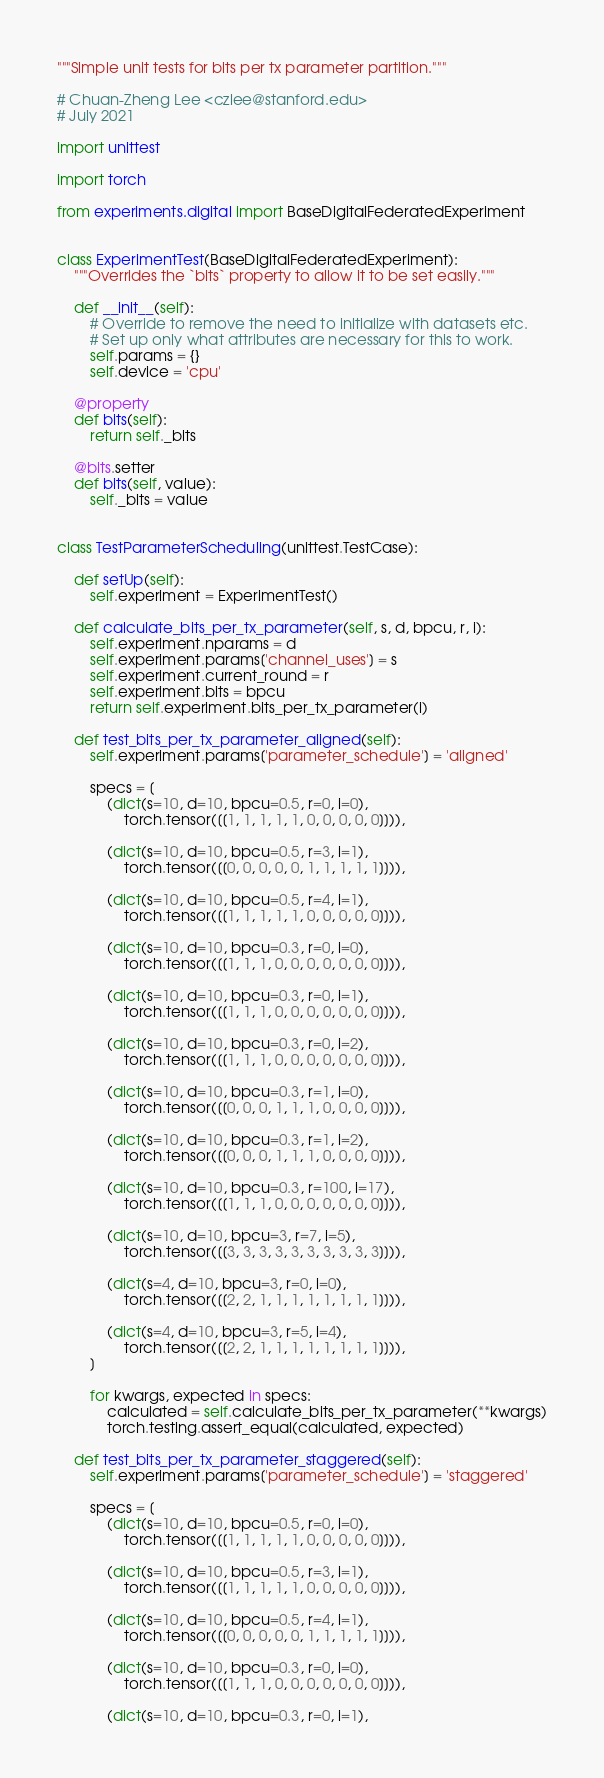Convert code to text. <code><loc_0><loc_0><loc_500><loc_500><_Python_>"""Simple unit tests for bits per tx parameter partition."""

# Chuan-Zheng Lee <czlee@stanford.edu>
# July 2021

import unittest

import torch

from experiments.digital import BaseDigitalFederatedExperiment


class ExperimentTest(BaseDigitalFederatedExperiment):
    """Overrides the `bits` property to allow it to be set easily."""

    def __init__(self):
        # Override to remove the need to initialize with datasets etc.
        # Set up only what attributes are necessary for this to work.
        self.params = {}
        self.device = 'cpu'

    @property
    def bits(self):
        return self._bits

    @bits.setter
    def bits(self, value):
        self._bits = value


class TestParameterScheduling(unittest.TestCase):

    def setUp(self):
        self.experiment = ExperimentTest()

    def calculate_bits_per_tx_parameter(self, s, d, bpcu, r, i):
        self.experiment.nparams = d
        self.experiment.params['channel_uses'] = s
        self.experiment.current_round = r
        self.experiment.bits = bpcu
        return self.experiment.bits_per_tx_parameter(i)

    def test_bits_per_tx_parameter_aligned(self):
        self.experiment.params['parameter_schedule'] = 'aligned'

        specs = [
            (dict(s=10, d=10, bpcu=0.5, r=0, i=0),
                torch.tensor([[1, 1, 1, 1, 1, 0, 0, 0, 0, 0]])),

            (dict(s=10, d=10, bpcu=0.5, r=3, i=1),
                torch.tensor([[0, 0, 0, 0, 0, 1, 1, 1, 1, 1]])),

            (dict(s=10, d=10, bpcu=0.5, r=4, i=1),
                torch.tensor([[1, 1, 1, 1, 1, 0, 0, 0, 0, 0]])),

            (dict(s=10, d=10, bpcu=0.3, r=0, i=0),
                torch.tensor([[1, 1, 1, 0, 0, 0, 0, 0, 0, 0]])),

            (dict(s=10, d=10, bpcu=0.3, r=0, i=1),
                torch.tensor([[1, 1, 1, 0, 0, 0, 0, 0, 0, 0]])),

            (dict(s=10, d=10, bpcu=0.3, r=0, i=2),
                torch.tensor([[1, 1, 1, 0, 0, 0, 0, 0, 0, 0]])),

            (dict(s=10, d=10, bpcu=0.3, r=1, i=0),
                torch.tensor([[0, 0, 0, 1, 1, 1, 0, 0, 0, 0]])),

            (dict(s=10, d=10, bpcu=0.3, r=1, i=2),
                torch.tensor([[0, 0, 0, 1, 1, 1, 0, 0, 0, 0]])),

            (dict(s=10, d=10, bpcu=0.3, r=100, i=17),
                torch.tensor([[1, 1, 1, 0, 0, 0, 0, 0, 0, 0]])),

            (dict(s=10, d=10, bpcu=3, r=7, i=5),
                torch.tensor([[3, 3, 3, 3, 3, 3, 3, 3, 3, 3]])),

            (dict(s=4, d=10, bpcu=3, r=0, i=0),
                torch.tensor([[2, 2, 1, 1, 1, 1, 1, 1, 1, 1]])),

            (dict(s=4, d=10, bpcu=3, r=5, i=4),
                torch.tensor([[2, 2, 1, 1, 1, 1, 1, 1, 1, 1]])),
        ]

        for kwargs, expected in specs:
            calculated = self.calculate_bits_per_tx_parameter(**kwargs)
            torch.testing.assert_equal(calculated, expected)

    def test_bits_per_tx_parameter_staggered(self):
        self.experiment.params['parameter_schedule'] = 'staggered'

        specs = [
            (dict(s=10, d=10, bpcu=0.5, r=0, i=0),
                torch.tensor([[1, 1, 1, 1, 1, 0, 0, 0, 0, 0]])),

            (dict(s=10, d=10, bpcu=0.5, r=3, i=1),
                torch.tensor([[1, 1, 1, 1, 1, 0, 0, 0, 0, 0]])),

            (dict(s=10, d=10, bpcu=0.5, r=4, i=1),
                torch.tensor([[0, 0, 0, 0, 0, 1, 1, 1, 1, 1]])),

            (dict(s=10, d=10, bpcu=0.3, r=0, i=0),
                torch.tensor([[1, 1, 1, 0, 0, 0, 0, 0, 0, 0]])),

            (dict(s=10, d=10, bpcu=0.3, r=0, i=1),</code> 